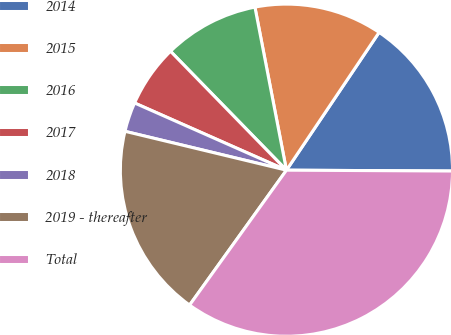Convert chart. <chart><loc_0><loc_0><loc_500><loc_500><pie_chart><fcel>2014<fcel>2015<fcel>2016<fcel>2017<fcel>2018<fcel>2019 - thereafter<fcel>Total<nl><fcel>15.66%<fcel>12.46%<fcel>9.26%<fcel>6.07%<fcel>2.87%<fcel>18.85%<fcel>34.83%<nl></chart> 